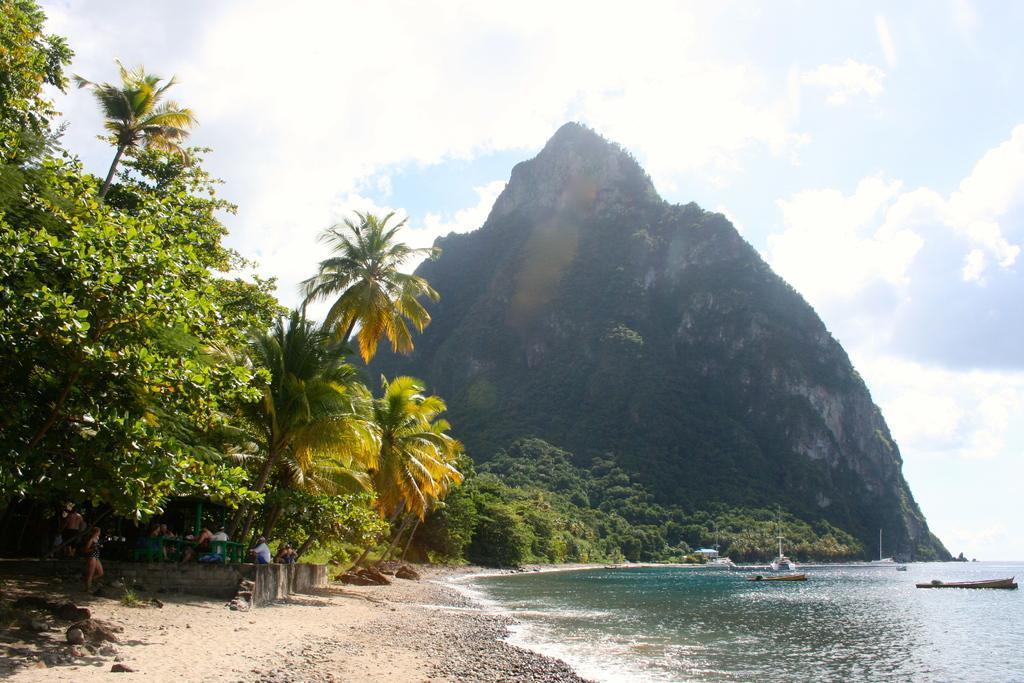How would you summarize this image in a sentence or two? Sky is cloudy. Here we can see a mountain, water and trees. Under these trees there are people. Above this water there are boats. 